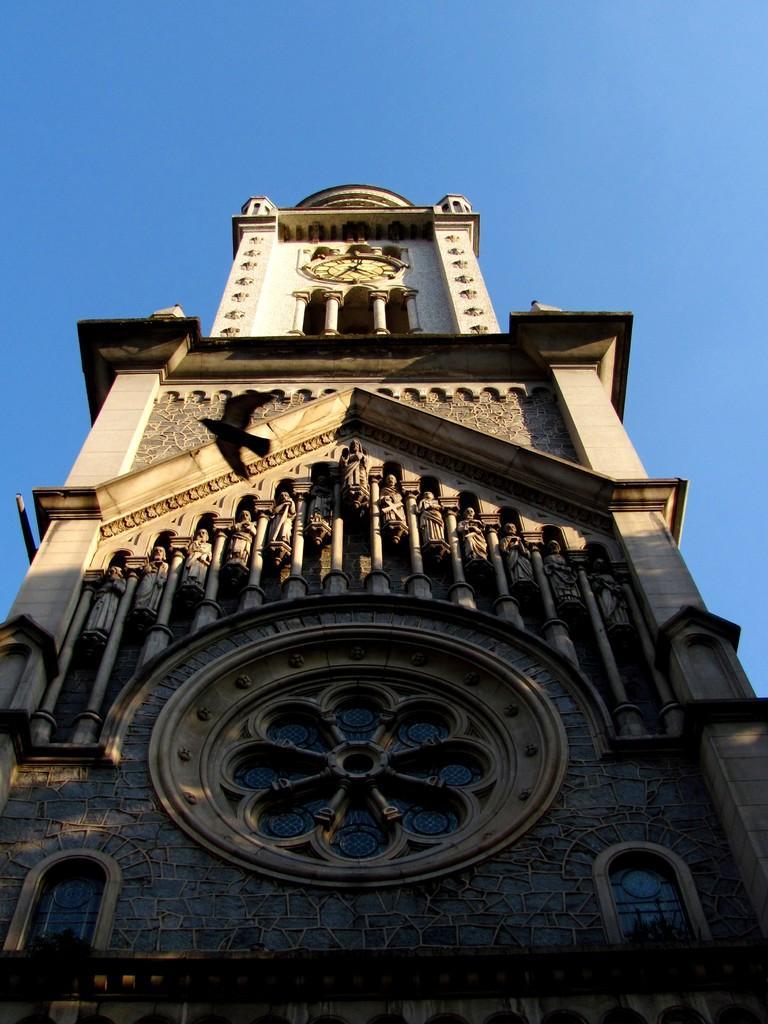Can you describe this image briefly? In the center of the image, we can see a clock tower and at the top, there is sky. 